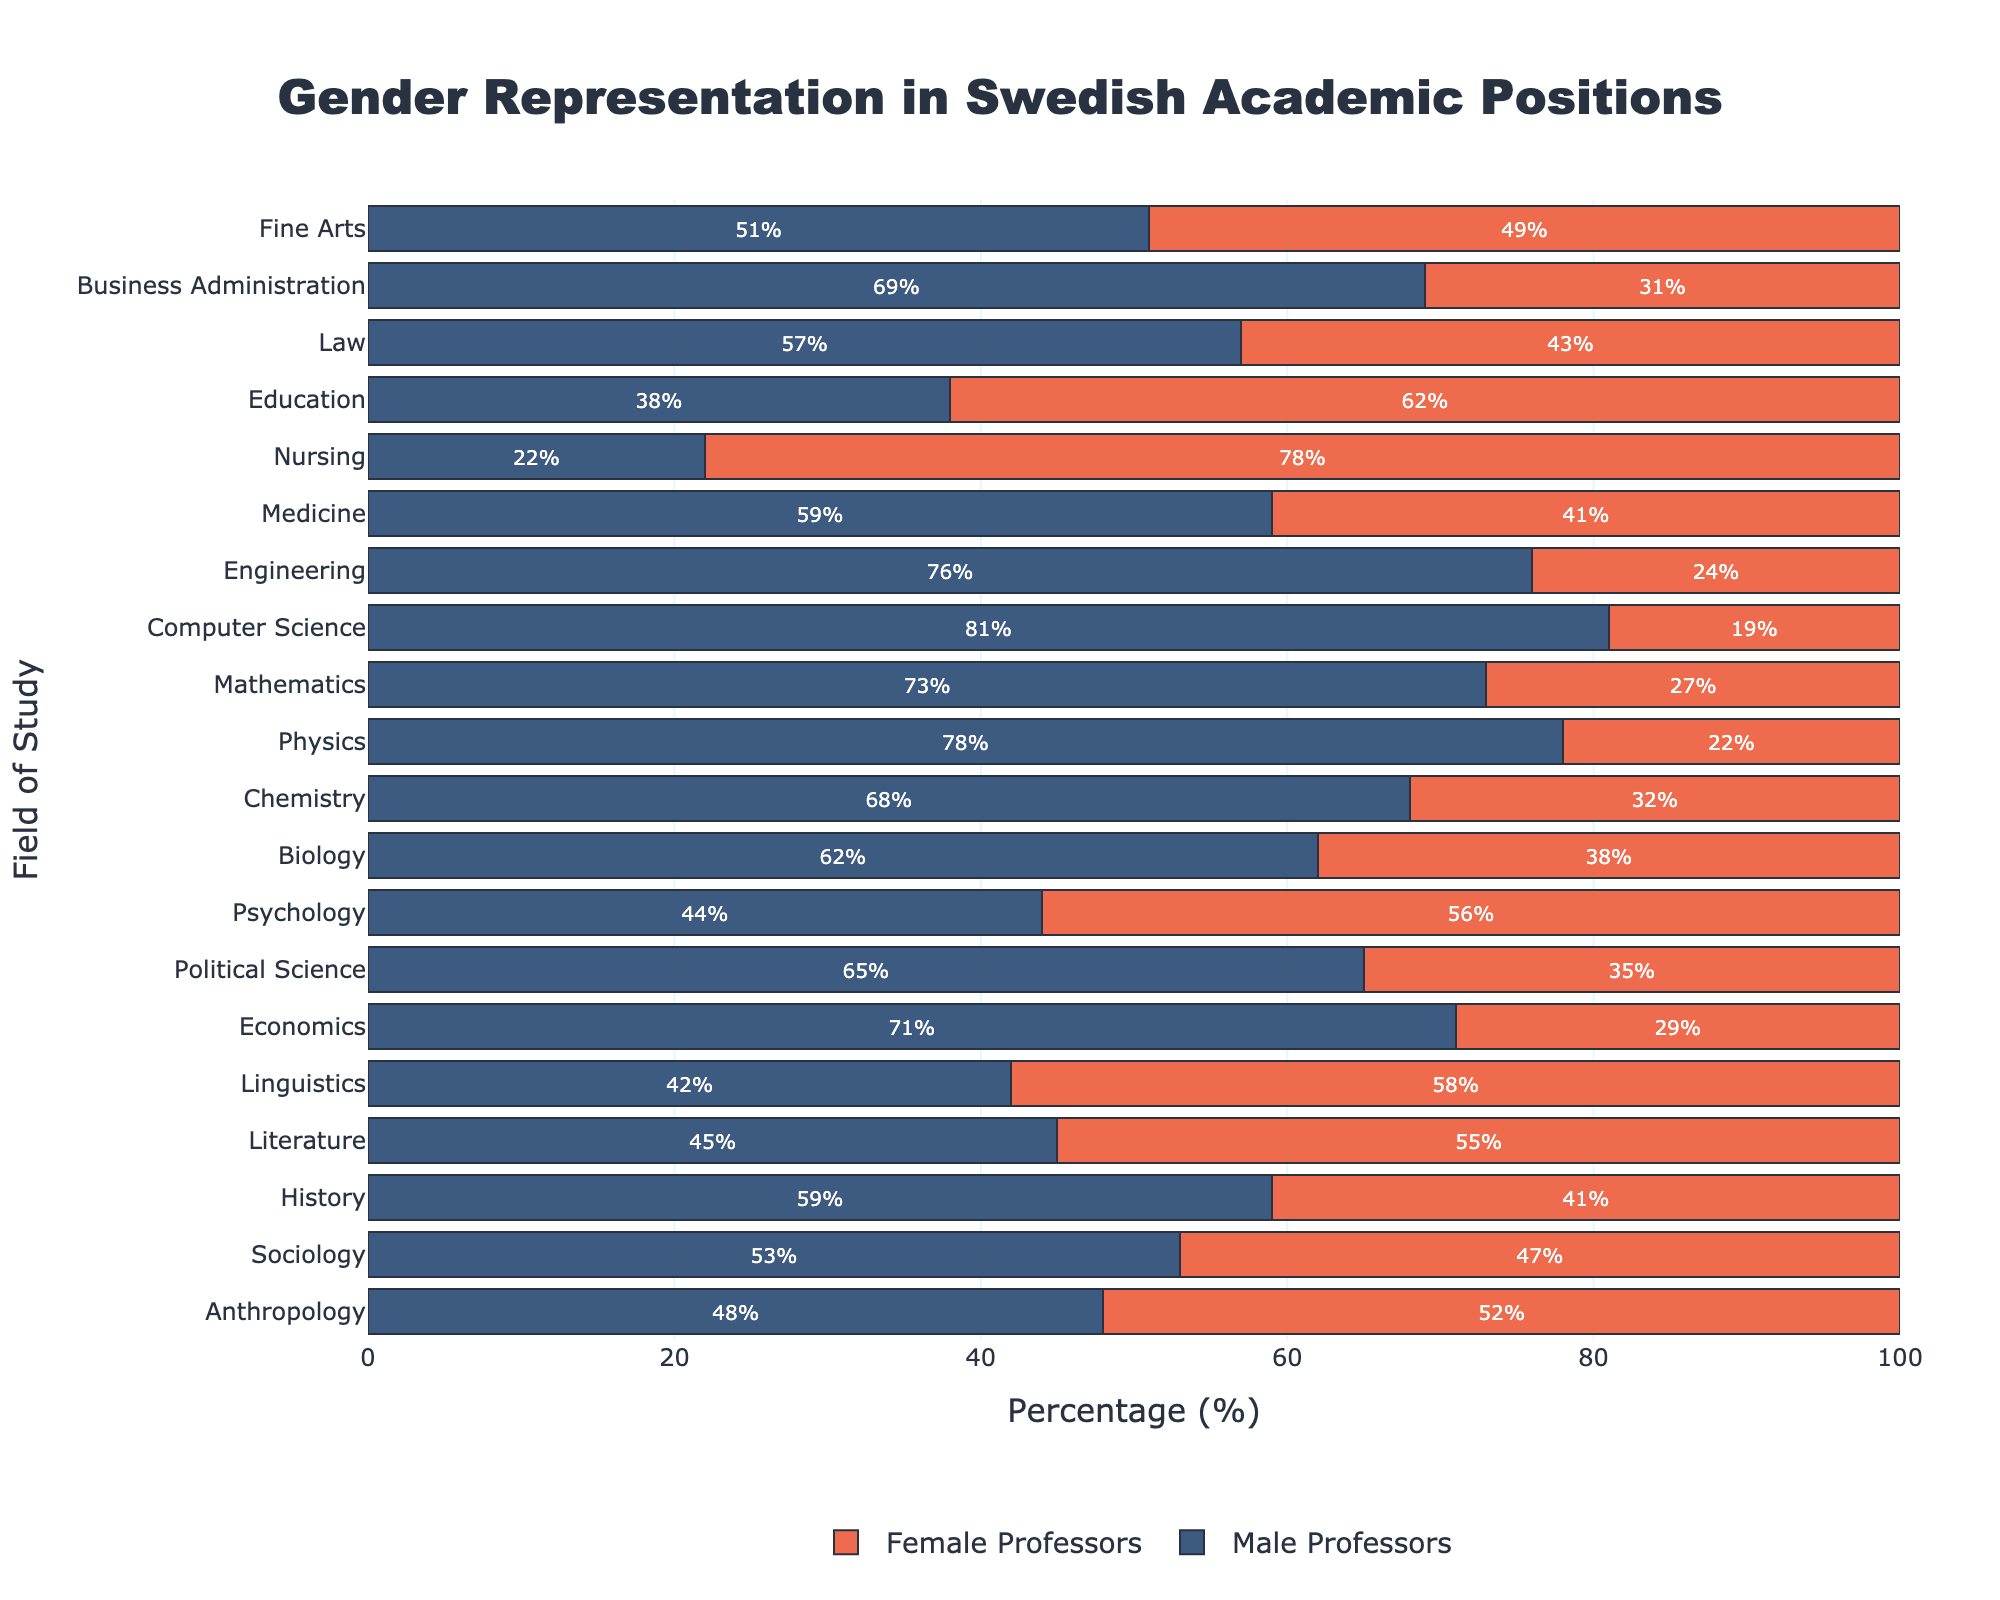What's the field with the highest percentage of male professors? Identify the bar representing the highest value for male professors. The figure shows that Computer Science has the highest percentage of male professors.
Answer: Computer Science Which field has the smallest gender gap in percentage? Look for the field where the difference between male and female percentages is the smallest. Fine Arts has a nearly balanced percentage with a 2% difference.
Answer: Fine Arts What’s the total percentage of female professors in Linguistics, Nursing, and Education? Sum the percentages of female professors in these three fields: Linguistics (58%) + Nursing (78%) + Education (62%). The total is 198%.
Answer: 198% In which field is the proportion of female professors more than double that of male professors? Compare each field to see if the percentage of female professors is more than twice the percentage of male professors. In Nursing, female professors are 78%, and male professors are 22%, which satisfies the criteria.
Answer: Nursing What is the average percentage of male professors in the fields of Engineering, Computer Science, and Mathematics? Find the sum of the percentages: Engineering (76%) + Computer Science (81%) + Mathematics (73%), which is 230%. Then divide by the number of fields: 230/3. The average is approximately 76.67%.
Answer: ~76.67% How many fields have equal or more female professors than male professors? Count the number of fields where the female percentage is equal to or greater than the male percentage. These fields are Anthropology, Literature, Linguistics, Psychology, Nursing, and Education (6 fields).
Answer: 6 fields Which field has the most similar gender representation to Business Administration? Compare the percentages in Business Administration (69% male, 31% female) to other fields to find the closest match. Chemistry (68% male, 32% female) is the closest to Business Administration.
Answer: Chemistry For which fields are female professors the majority? Identify fields where the percentage of female professors is greater than 50%. These fields are Anthropology, Literature, Linguistics, Psychology, Nursing, and Education.
Answer: 6 fields How does the gender balance in Law compare to that in Sociology? Law has 57% male and 43% female professors; Sociology has 53% male and 47% female professors. Thus, the gender gap is smaller in Sociology.
Answer: Sociology has a smaller gender gap In how many fields is the gender representation of male professors above 70%? Count the number of fields where the male percentage is more than 70%. These fields are Economics, Physics, Mathematics, Computer Science, and Engineering (5 fields).
Answer: 5 fields 